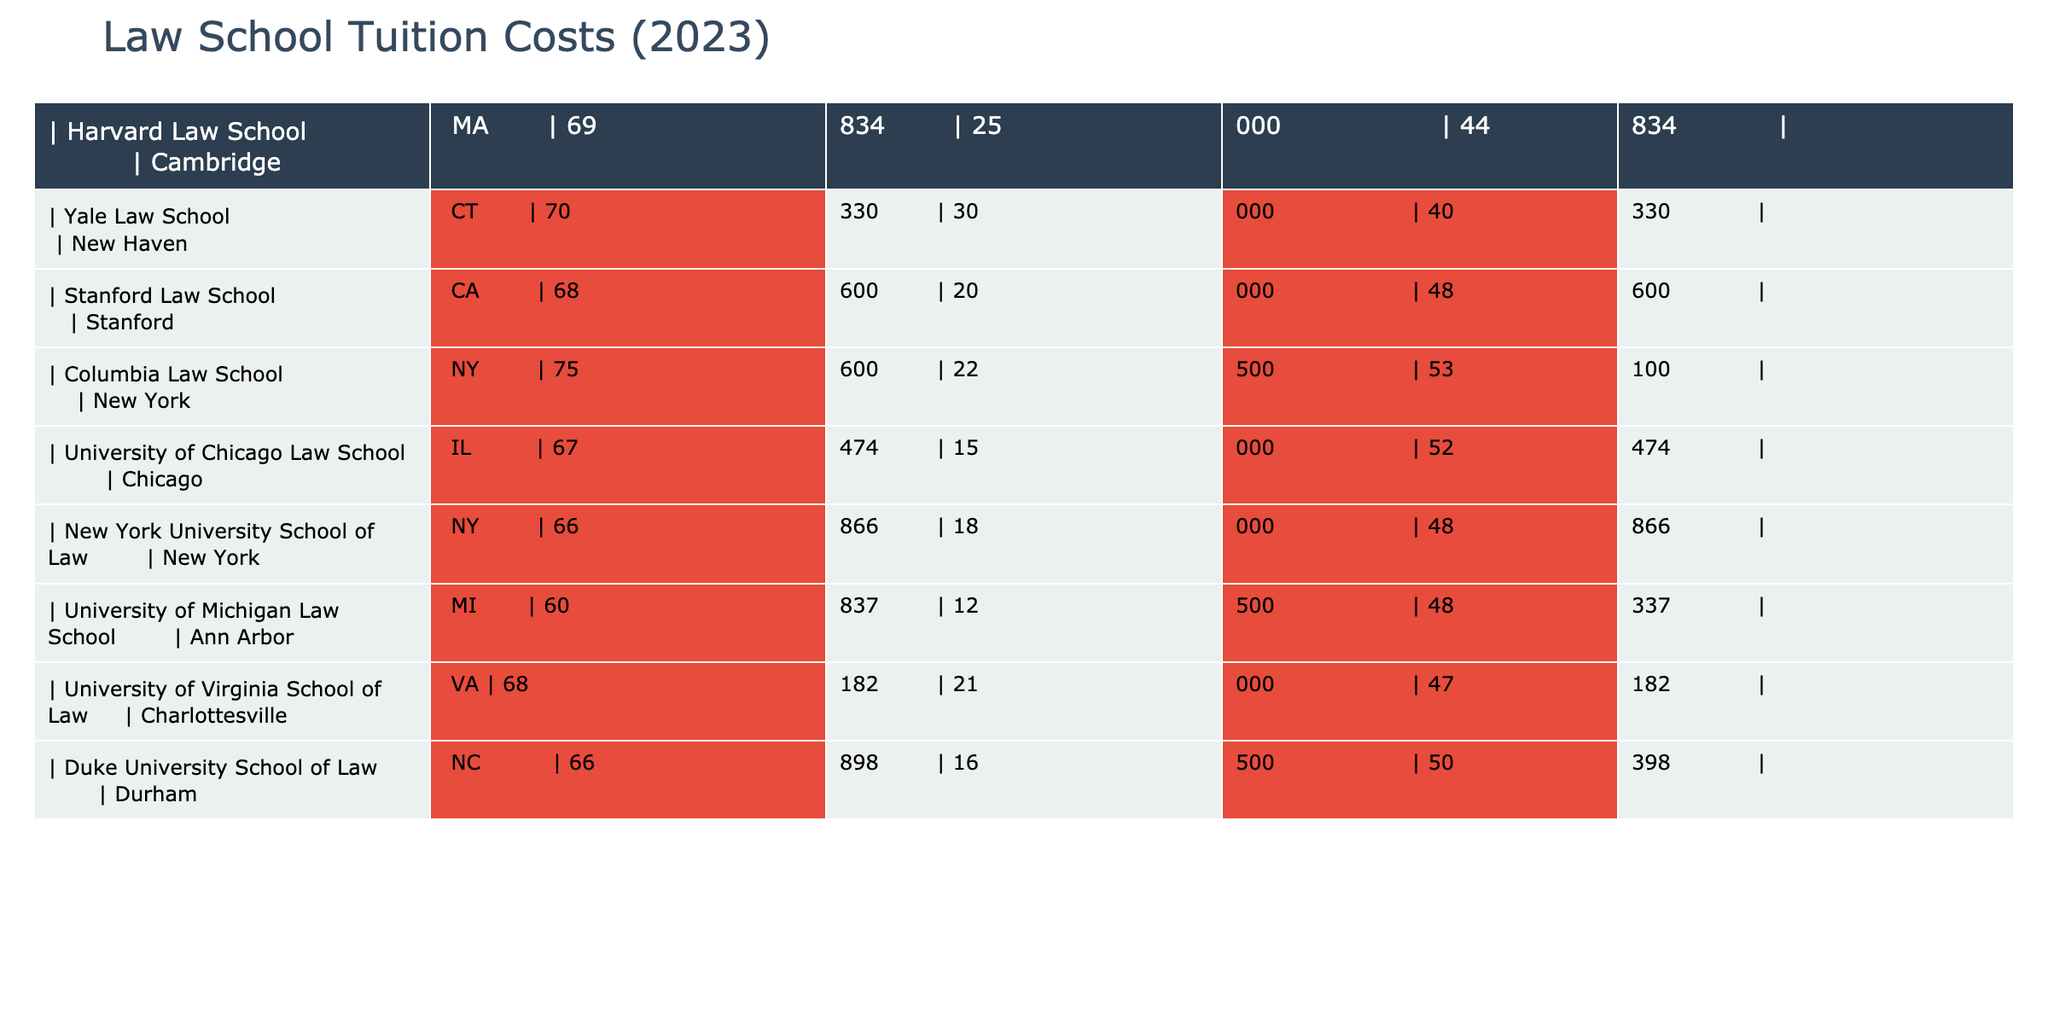What is the highest tuition cost among the law schools listed? By scanning through the tuition values in the table, Columbia Law School has the highest tuition cost at $75,600.
Answer: $75,600 Which law school has the lowest net cost after fees? The net cost is calculated by subtracting the financial aid from the total tuition. University of Michigan Law School has the lowest net cost of $48,337 ($60,837 - $12,500).
Answer: $48,337 What is the average tuition cost of the law schools listed? To find the average, first sum all the tuition costs: $69,834 + $70,330 + $68,600 + $75,600 + $67,474 + $66,866 + $60,837 + $68,182 + $66,898 = $ 609,621. There are 9 law schools, so the average is $609,621 / 9 ≈ $67,736.78.
Answer: $67,736.78 Is Yale Law School's total tuition greater than Duke University's? Yale Law School's tuition is $70,330, and Duke University's is $66,898. Since $70,330 > $66,898, the statement is true.
Answer: Yes If we add the financial aid values for Harvard Law School and Stanford Law School, what will be the total? Harvard's financial aid is $25,000 and Stanford's is $20,000. Adding these gives $25,000 + $20,000 = $45,000.
Answer: $45,000 Which law school has a net cost closest to $50,000? Net costs can be calculated by subtracting financial aid from tuition. The net costs are: Harvard: $44,834, Yale: $40,330, Stanford: $48,600, Columbia: $53,100, Chicago: $52,474, NYU: $48,866, Michigan: $48,337, Virginia: $47,182, Duke: $50,398. Duke University's net cost of $50,398 is closest to $50,000.
Answer: Duke University What is the overall financial aid amount provided by the University of Virginia compared to New York University? The financial aid at University of Virginia is $21,000 while at New York University it is $18,000. Since $21,000 > $18,000, University of Virginia offers more financial aid.
Answer: Yes What is the difference between the tuition of Harvard Law School and the University of Chicago Law School? Harvard's tuition is $69,834 and Chicago's tuition is $67,474. The difference is $69,834 - $67,474 = $2,360.
Answer: $2,360 Which two law schools combined have total tuition costs that exceed $150,000? We can test pairs of schools. Harvard ($69,834) + Columbia ($75,600) = $145,434; Harvard + Yale ($70,330) = $140,164; NYU ($66,866) + Michigan ($60,837) = $127,703; Duke + Chicago ($66,898 + $67,474) = $134,372; but, Columbia + Yale ($75,600 + $70,330) = $145,930, still under $150,000. Checking Stanford + Yale ($68,600 + $70,330) = $138,930. None of these pairs exceed $150,000.
Answer: None found exceeding $150,000 